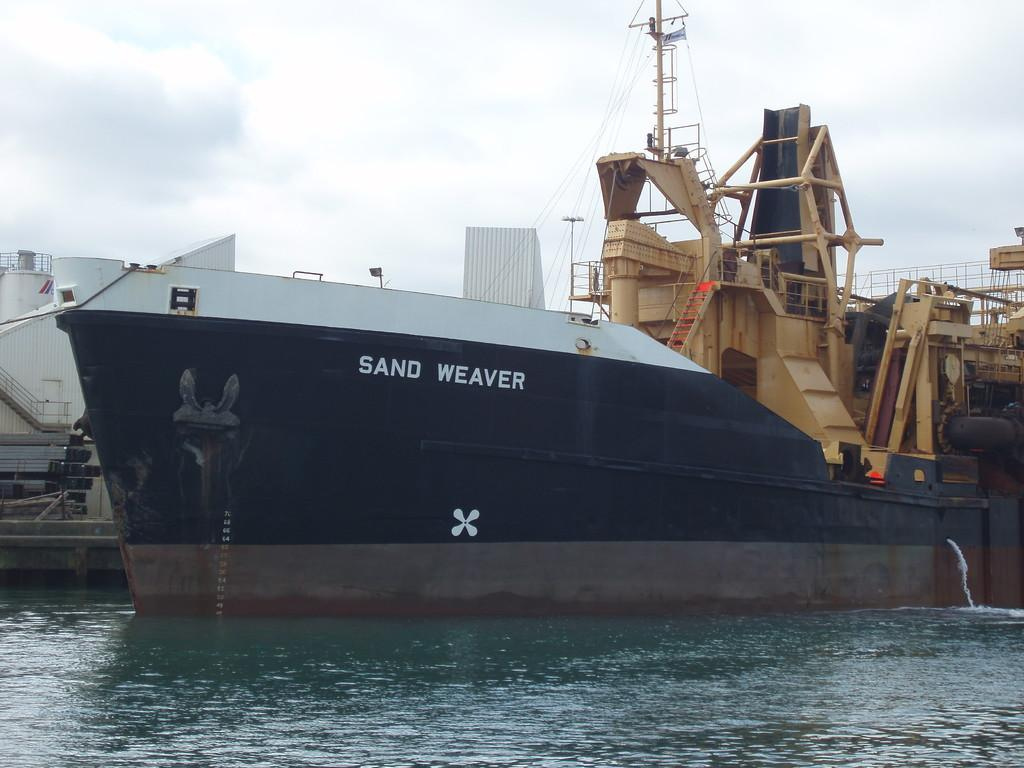<image>
Give a short and clear explanation of the subsequent image. The black and white boat is named Sand Weaver. 